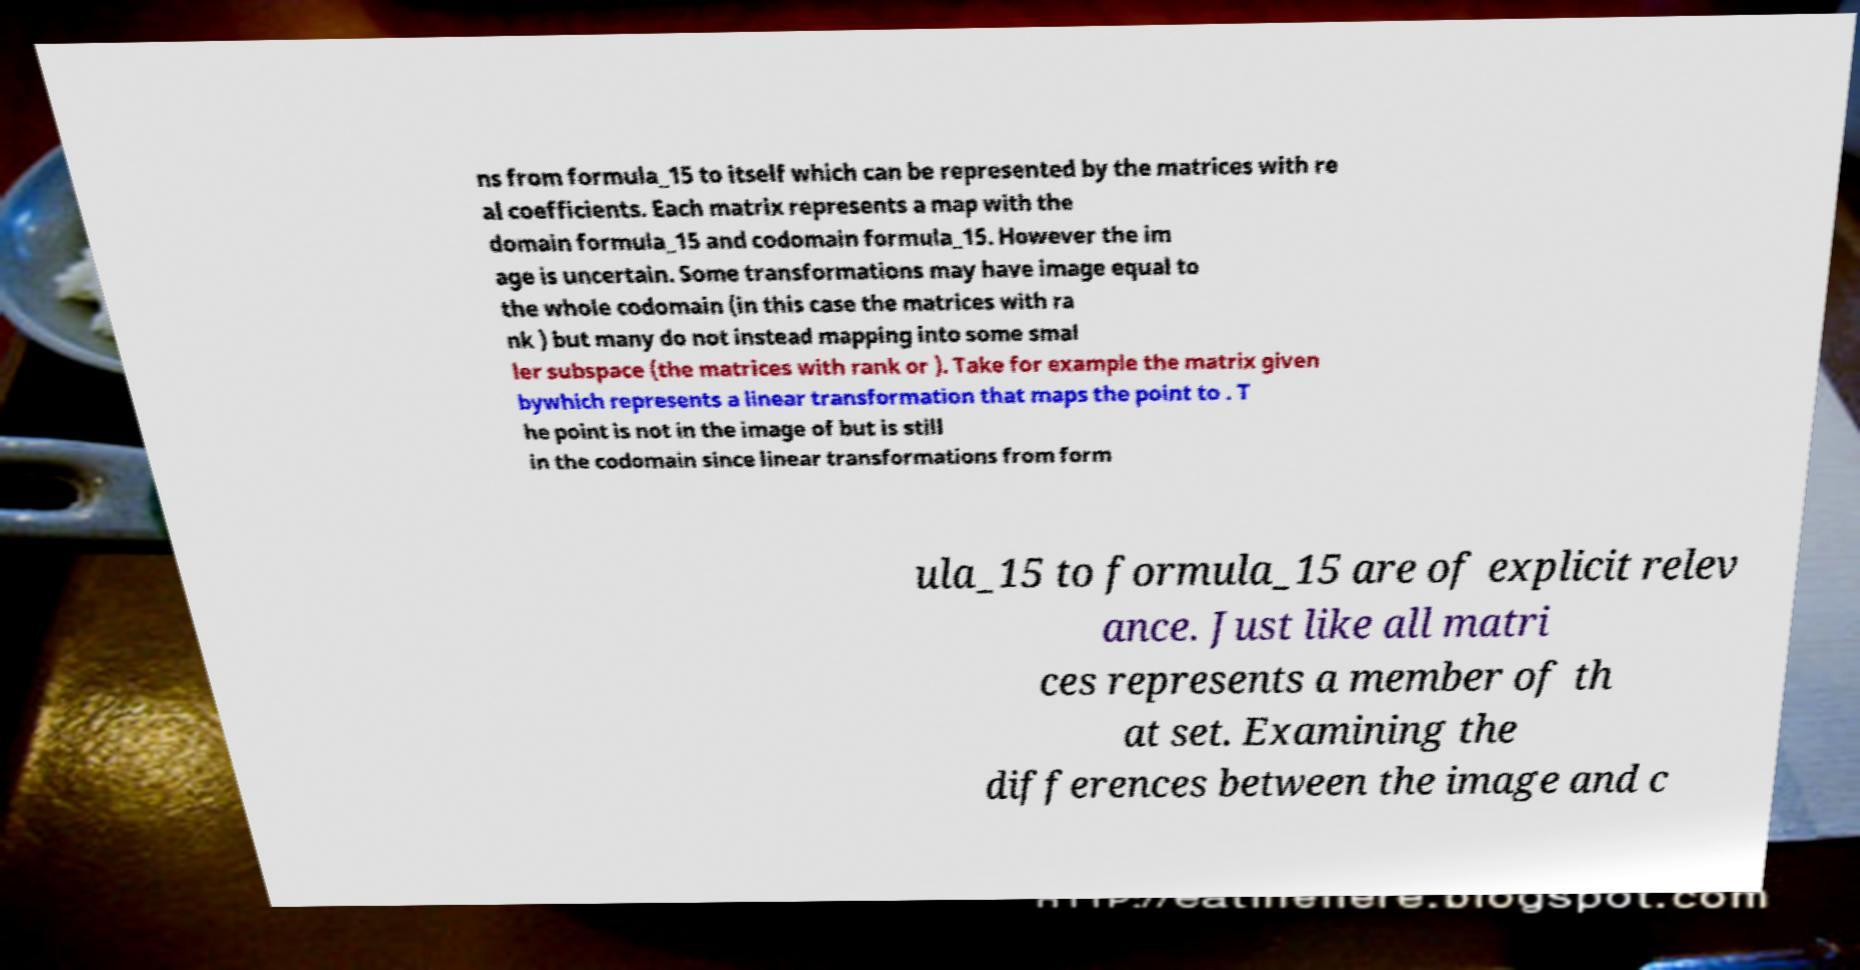There's text embedded in this image that I need extracted. Can you transcribe it verbatim? ns from formula_15 to itself which can be represented by the matrices with re al coefficients. Each matrix represents a map with the domain formula_15 and codomain formula_15. However the im age is uncertain. Some transformations may have image equal to the whole codomain (in this case the matrices with ra nk ) but many do not instead mapping into some smal ler subspace (the matrices with rank or ). Take for example the matrix given bywhich represents a linear transformation that maps the point to . T he point is not in the image of but is still in the codomain since linear transformations from form ula_15 to formula_15 are of explicit relev ance. Just like all matri ces represents a member of th at set. Examining the differences between the image and c 